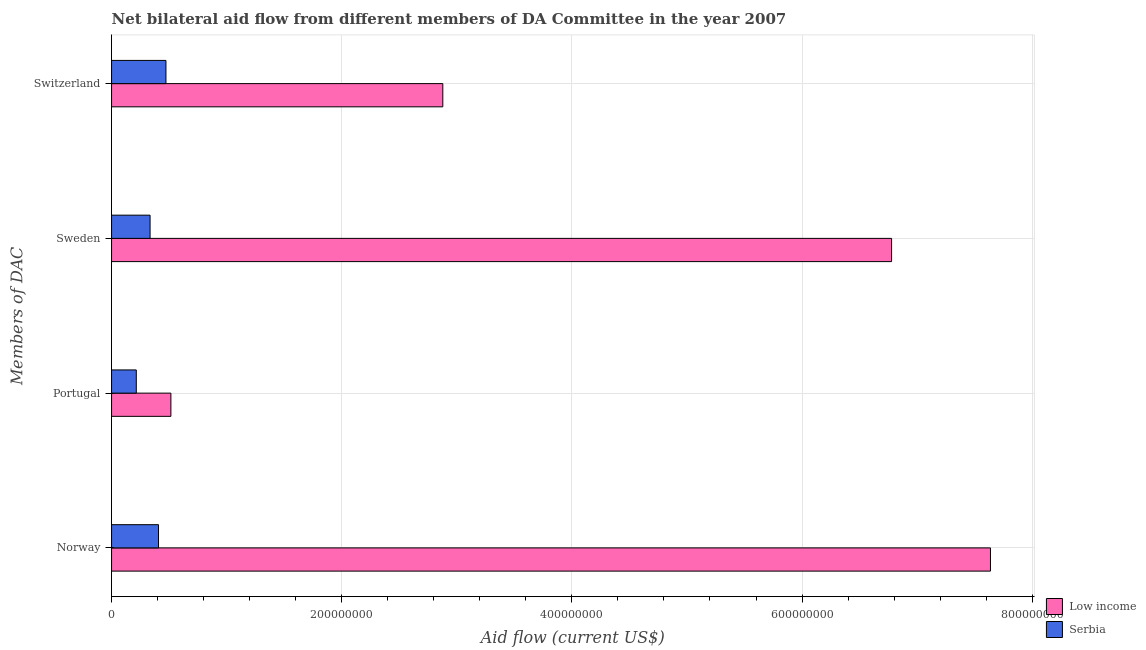How many different coloured bars are there?
Your answer should be compact. 2. How many groups of bars are there?
Provide a succinct answer. 4. How many bars are there on the 1st tick from the bottom?
Your response must be concise. 2. What is the label of the 2nd group of bars from the top?
Ensure brevity in your answer.  Sweden. What is the amount of aid given by portugal in Low income?
Offer a terse response. 5.16e+07. Across all countries, what is the maximum amount of aid given by portugal?
Keep it short and to the point. 5.16e+07. Across all countries, what is the minimum amount of aid given by switzerland?
Make the answer very short. 4.73e+07. In which country was the amount of aid given by norway maximum?
Keep it short and to the point. Low income. In which country was the amount of aid given by sweden minimum?
Provide a succinct answer. Serbia. What is the total amount of aid given by sweden in the graph?
Offer a terse response. 7.11e+08. What is the difference between the amount of aid given by norway in Low income and that in Serbia?
Keep it short and to the point. 7.23e+08. What is the difference between the amount of aid given by switzerland in Serbia and the amount of aid given by portugal in Low income?
Provide a succinct answer. -4.29e+06. What is the average amount of aid given by portugal per country?
Provide a succinct answer. 3.65e+07. What is the difference between the amount of aid given by sweden and amount of aid given by portugal in Serbia?
Give a very brief answer. 1.20e+07. In how many countries, is the amount of aid given by sweden greater than 560000000 US$?
Provide a short and direct response. 1. What is the ratio of the amount of aid given by sweden in Serbia to that in Low income?
Make the answer very short. 0.05. What is the difference between the highest and the second highest amount of aid given by switzerland?
Make the answer very short. 2.41e+08. What is the difference between the highest and the lowest amount of aid given by switzerland?
Keep it short and to the point. 2.41e+08. What does the 2nd bar from the top in Switzerland represents?
Your answer should be compact. Low income. What does the 2nd bar from the bottom in Sweden represents?
Your answer should be very brief. Serbia. Is it the case that in every country, the sum of the amount of aid given by norway and amount of aid given by portugal is greater than the amount of aid given by sweden?
Keep it short and to the point. Yes. How many bars are there?
Your answer should be compact. 8. How many countries are there in the graph?
Offer a very short reply. 2. What is the difference between two consecutive major ticks on the X-axis?
Make the answer very short. 2.00e+08. Does the graph contain any zero values?
Offer a terse response. No. Does the graph contain grids?
Provide a succinct answer. Yes. Where does the legend appear in the graph?
Your answer should be compact. Bottom right. What is the title of the graph?
Provide a short and direct response. Net bilateral aid flow from different members of DA Committee in the year 2007. What is the label or title of the X-axis?
Your answer should be very brief. Aid flow (current US$). What is the label or title of the Y-axis?
Make the answer very short. Members of DAC. What is the Aid flow (current US$) of Low income in Norway?
Offer a terse response. 7.64e+08. What is the Aid flow (current US$) of Serbia in Norway?
Make the answer very short. 4.08e+07. What is the Aid flow (current US$) of Low income in Portugal?
Offer a very short reply. 5.16e+07. What is the Aid flow (current US$) of Serbia in Portugal?
Your response must be concise. 2.15e+07. What is the Aid flow (current US$) of Low income in Sweden?
Offer a very short reply. 6.78e+08. What is the Aid flow (current US$) in Serbia in Sweden?
Provide a short and direct response. 3.35e+07. What is the Aid flow (current US$) in Low income in Switzerland?
Offer a terse response. 2.88e+08. What is the Aid flow (current US$) of Serbia in Switzerland?
Your answer should be very brief. 4.73e+07. Across all Members of DAC, what is the maximum Aid flow (current US$) of Low income?
Your answer should be compact. 7.64e+08. Across all Members of DAC, what is the maximum Aid flow (current US$) of Serbia?
Make the answer very short. 4.73e+07. Across all Members of DAC, what is the minimum Aid flow (current US$) of Low income?
Ensure brevity in your answer.  5.16e+07. Across all Members of DAC, what is the minimum Aid flow (current US$) in Serbia?
Give a very brief answer. 2.15e+07. What is the total Aid flow (current US$) of Low income in the graph?
Provide a succinct answer. 1.78e+09. What is the total Aid flow (current US$) of Serbia in the graph?
Offer a very short reply. 1.43e+08. What is the difference between the Aid flow (current US$) in Low income in Norway and that in Portugal?
Your answer should be compact. 7.12e+08. What is the difference between the Aid flow (current US$) in Serbia in Norway and that in Portugal?
Provide a succinct answer. 1.93e+07. What is the difference between the Aid flow (current US$) of Low income in Norway and that in Sweden?
Offer a terse response. 8.59e+07. What is the difference between the Aid flow (current US$) in Serbia in Norway and that in Sweden?
Give a very brief answer. 7.33e+06. What is the difference between the Aid flow (current US$) in Low income in Norway and that in Switzerland?
Keep it short and to the point. 4.76e+08. What is the difference between the Aid flow (current US$) in Serbia in Norway and that in Switzerland?
Your response must be concise. -6.47e+06. What is the difference between the Aid flow (current US$) of Low income in Portugal and that in Sweden?
Your answer should be compact. -6.26e+08. What is the difference between the Aid flow (current US$) in Serbia in Portugal and that in Sweden?
Offer a terse response. -1.20e+07. What is the difference between the Aid flow (current US$) in Low income in Portugal and that in Switzerland?
Provide a short and direct response. -2.36e+08. What is the difference between the Aid flow (current US$) in Serbia in Portugal and that in Switzerland?
Your answer should be very brief. -2.58e+07. What is the difference between the Aid flow (current US$) of Low income in Sweden and that in Switzerland?
Provide a short and direct response. 3.90e+08. What is the difference between the Aid flow (current US$) in Serbia in Sweden and that in Switzerland?
Make the answer very short. -1.38e+07. What is the difference between the Aid flow (current US$) in Low income in Norway and the Aid flow (current US$) in Serbia in Portugal?
Your answer should be very brief. 7.42e+08. What is the difference between the Aid flow (current US$) in Low income in Norway and the Aid flow (current US$) in Serbia in Sweden?
Make the answer very short. 7.30e+08. What is the difference between the Aid flow (current US$) in Low income in Norway and the Aid flow (current US$) in Serbia in Switzerland?
Your response must be concise. 7.16e+08. What is the difference between the Aid flow (current US$) of Low income in Portugal and the Aid flow (current US$) of Serbia in Sweden?
Keep it short and to the point. 1.81e+07. What is the difference between the Aid flow (current US$) of Low income in Portugal and the Aid flow (current US$) of Serbia in Switzerland?
Offer a terse response. 4.29e+06. What is the difference between the Aid flow (current US$) in Low income in Sweden and the Aid flow (current US$) in Serbia in Switzerland?
Provide a succinct answer. 6.31e+08. What is the average Aid flow (current US$) in Low income per Members of DAC?
Provide a short and direct response. 4.45e+08. What is the average Aid flow (current US$) in Serbia per Members of DAC?
Your response must be concise. 3.58e+07. What is the difference between the Aid flow (current US$) of Low income and Aid flow (current US$) of Serbia in Norway?
Give a very brief answer. 7.23e+08. What is the difference between the Aid flow (current US$) of Low income and Aid flow (current US$) of Serbia in Portugal?
Provide a short and direct response. 3.01e+07. What is the difference between the Aid flow (current US$) of Low income and Aid flow (current US$) of Serbia in Sweden?
Offer a very short reply. 6.44e+08. What is the difference between the Aid flow (current US$) in Low income and Aid flow (current US$) in Serbia in Switzerland?
Offer a terse response. 2.41e+08. What is the ratio of the Aid flow (current US$) of Low income in Norway to that in Portugal?
Your response must be concise. 14.81. What is the ratio of the Aid flow (current US$) in Serbia in Norway to that in Portugal?
Ensure brevity in your answer.  1.9. What is the ratio of the Aid flow (current US$) in Low income in Norway to that in Sweden?
Ensure brevity in your answer.  1.13. What is the ratio of the Aid flow (current US$) in Serbia in Norway to that in Sweden?
Make the answer very short. 1.22. What is the ratio of the Aid flow (current US$) in Low income in Norway to that in Switzerland?
Provide a short and direct response. 2.65. What is the ratio of the Aid flow (current US$) of Serbia in Norway to that in Switzerland?
Offer a terse response. 0.86. What is the ratio of the Aid flow (current US$) in Low income in Portugal to that in Sweden?
Your response must be concise. 0.08. What is the ratio of the Aid flow (current US$) of Serbia in Portugal to that in Sweden?
Offer a terse response. 0.64. What is the ratio of the Aid flow (current US$) of Low income in Portugal to that in Switzerland?
Your answer should be very brief. 0.18. What is the ratio of the Aid flow (current US$) of Serbia in Portugal to that in Switzerland?
Ensure brevity in your answer.  0.45. What is the ratio of the Aid flow (current US$) of Low income in Sweden to that in Switzerland?
Keep it short and to the point. 2.35. What is the ratio of the Aid flow (current US$) in Serbia in Sweden to that in Switzerland?
Your answer should be very brief. 0.71. What is the difference between the highest and the second highest Aid flow (current US$) in Low income?
Provide a succinct answer. 8.59e+07. What is the difference between the highest and the second highest Aid flow (current US$) in Serbia?
Provide a short and direct response. 6.47e+06. What is the difference between the highest and the lowest Aid flow (current US$) in Low income?
Your response must be concise. 7.12e+08. What is the difference between the highest and the lowest Aid flow (current US$) of Serbia?
Ensure brevity in your answer.  2.58e+07. 